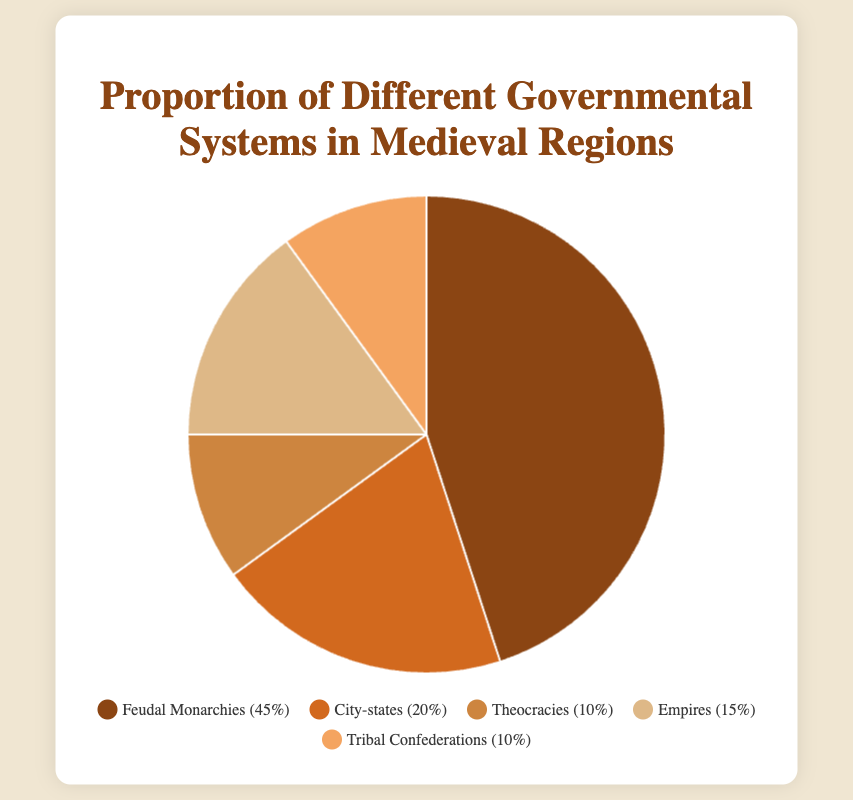What percentage of regions were governed by Feudal Monarchies? This question asks specifically for the percentage value associated with Feudal Monarchies. To find the answer, look at the segment labeled 'Feudal Monarchies' in the pie chart.
Answer: 45% What is the combined percentage of regions governed by Theocracies and Tribal Confederations? To find the combined percentage, add the percentages for Theocracies (10%) and Tribal Confederations (10%).
Answer: 20% Which governmental system has the second-highest proportion after Feudal Monarchies? First, identify the highest proportion, which is Feudal Monarchies at 45%. Then, look for the next highest value. City-states have the next highest percentage at 20%.
Answer: City-states How much greater is the proportion of Empires compared to Theocracies? Subtract the percentage of Theocracies (10%) from the percentage of Empires (15%).
Answer: 5% What fraction of the total regions were governed by either City-states or Empires? Add the percentages for City-states (20%) and Empires (15%), resulting in 35%. Since 100% represents the total, the fraction is 35/100, which simplifies to 7/20.
Answer: 7/20 Which governmental system has the smallest representation, and what is its percentage? Identify the system with the smallest percentage value shown on the pie chart. Both Theocracies and Tribal Confederations have the smallest representation at 10% each.
Answer: Theocracies and Tribal Confederations (10%) If you were to combine the regions governed by Theocracies, Empires, and Tribal Confederations, what would their total proportion be? Add the percentages of Theocracies (10%), Empires (15%), and Tribal Confederations (10%). This results in 35%.
Answer: 35% Visually, which segment appears to occupy the largest area of the pie chart? The segment corresponding to the category labeled 'Feudal Monarchies' visually occupies the largest area.
Answer: Feudal Monarchies What percentage of regions fall under categories other than Feudal Monarchies? To find this, subtract the percentage of Feudal Monarchies (45%) from the total (100%).
Answer: 55% Which governmental systems have equivalent proportions, and what are their percentages? Look for segments with identical percentage values. Both Theocracies and Tribal Confederations have an equal proportion of 10%.
Answer: Theocracies and Tribal Confederations (10%) 